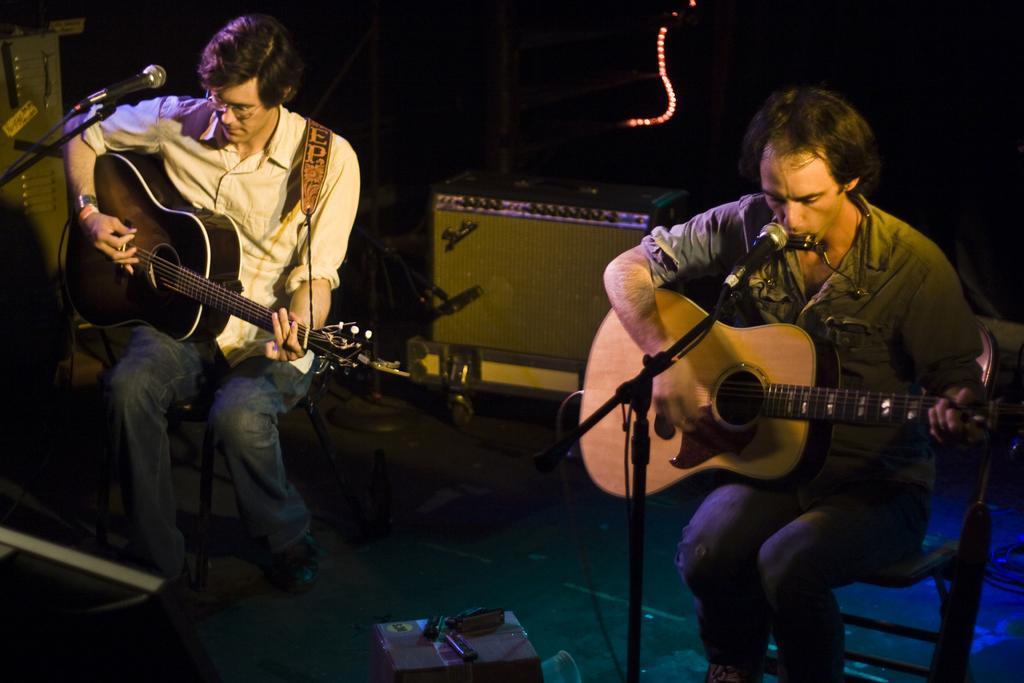How would you summarize this image in a sentence or two? In the picture there are two people sitting and playing guitars. The man to the right is signing as well as playing guitar. the man to the left is wearing spectacles. In front of them there is a microphone and its stand. On the floor there is box. In background there is a container. 